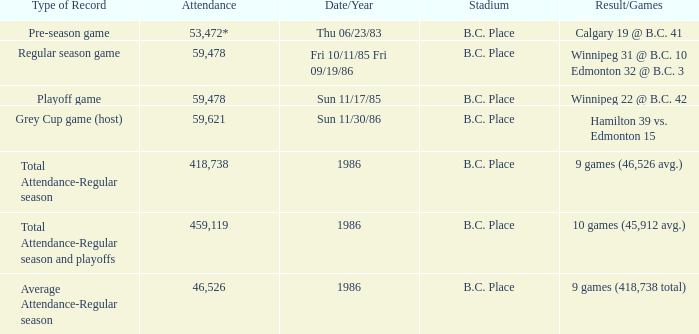What was the stadium that had the regular season game? B.C. Place. 